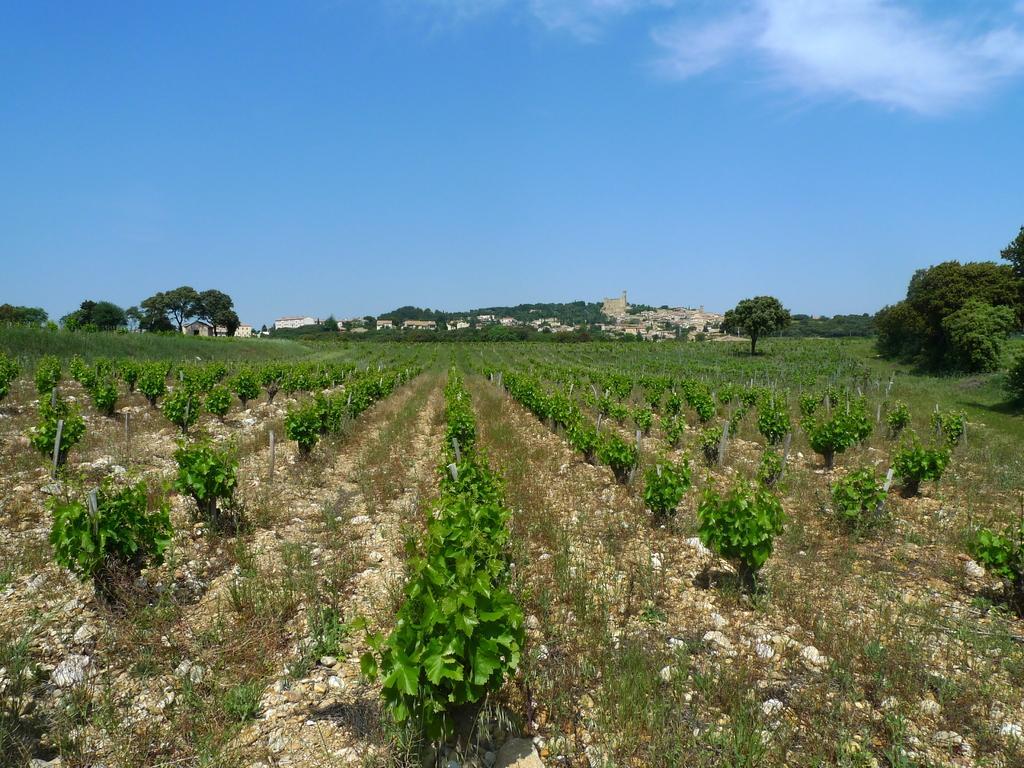How would you summarize this image in a sentence or two? In the foreground of the picture there is a field, in the field there are plants, grass and stones. In the background there are trees, buildings and other objects. Sky is clear and it is sunny. 